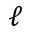<formula> <loc_0><loc_0><loc_500><loc_500>\ell</formula> 